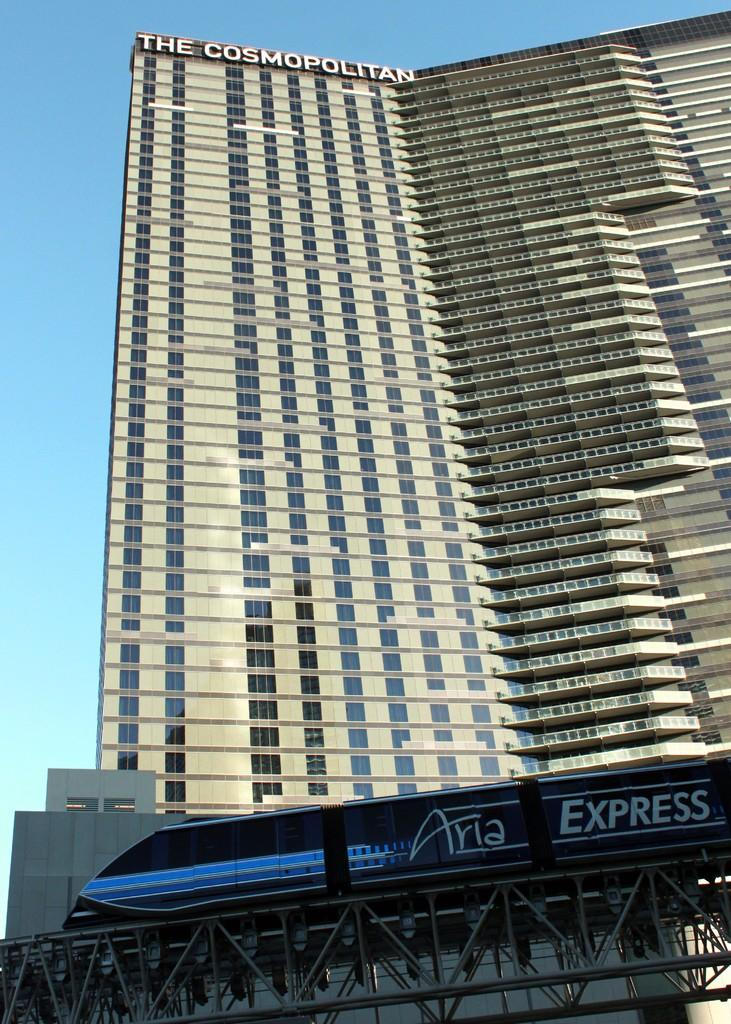Provide a one-sentence caption for the provided image. The Cosmopolitan shown from the ground looking up. 